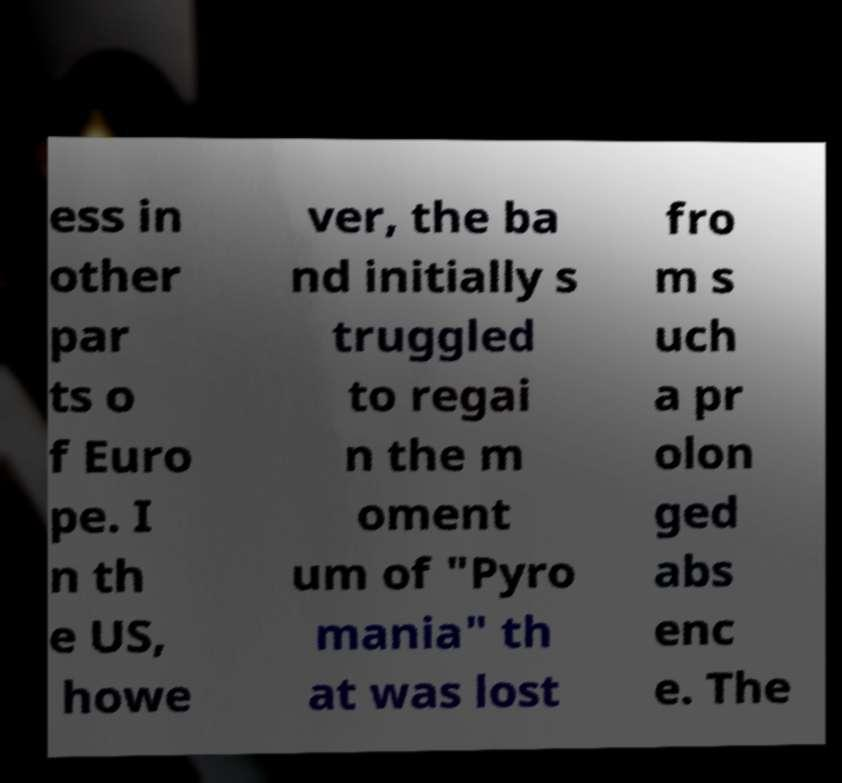For documentation purposes, I need the text within this image transcribed. Could you provide that? ess in other par ts o f Euro pe. I n th e US, howe ver, the ba nd initially s truggled to regai n the m oment um of "Pyro mania" th at was lost fro m s uch a pr olon ged abs enc e. The 